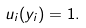Convert formula to latex. <formula><loc_0><loc_0><loc_500><loc_500>u _ { i } ( y _ { i } ) = 1 .</formula> 